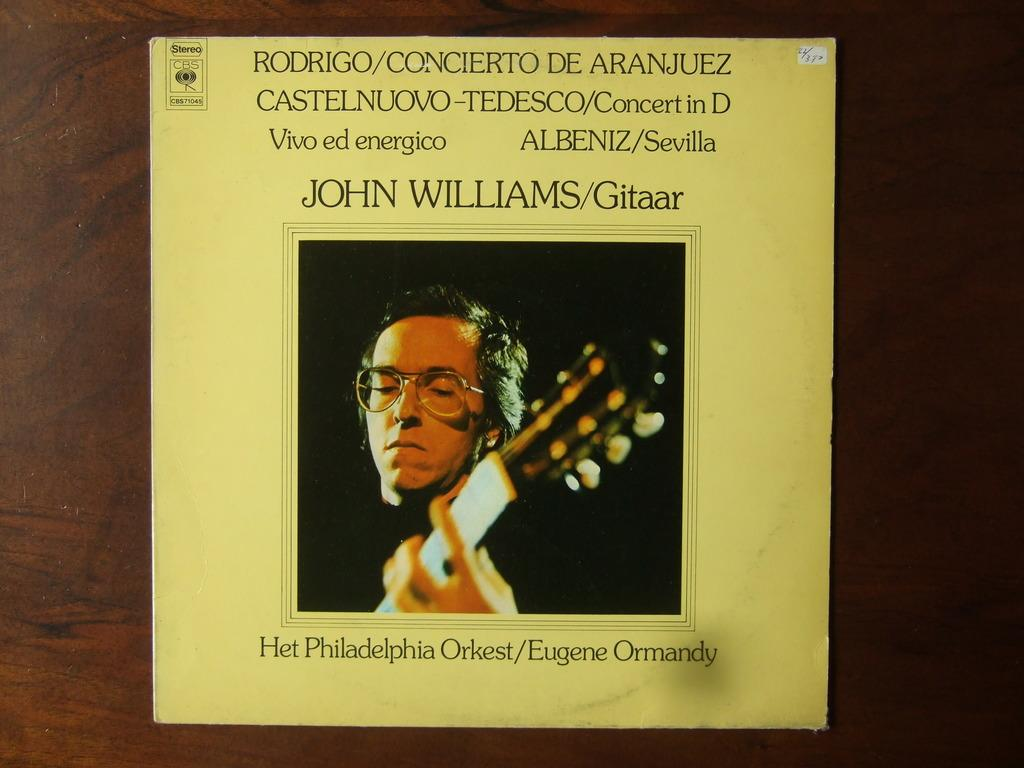<image>
Give a short and clear explanation of the subsequent image. A yellow colored album named Het Philadelphia Orkest. 